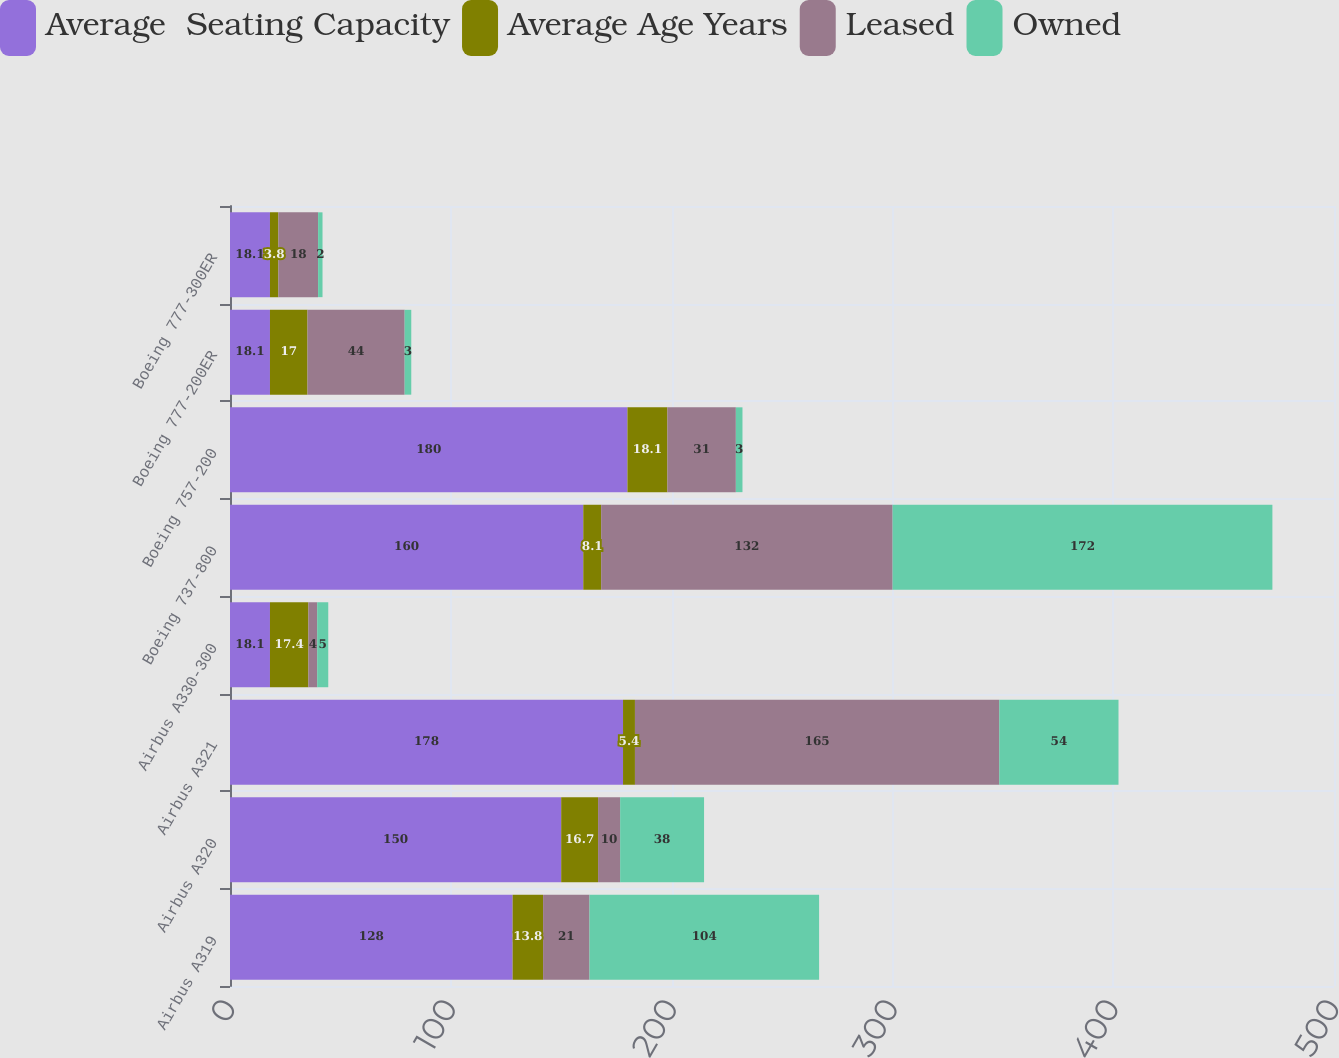Convert chart. <chart><loc_0><loc_0><loc_500><loc_500><stacked_bar_chart><ecel><fcel>Airbus A319<fcel>Airbus A320<fcel>Airbus A321<fcel>Airbus A330-300<fcel>Boeing 737-800<fcel>Boeing 757-200<fcel>Boeing 777-200ER<fcel>Boeing 777-300ER<nl><fcel>Average  Seating Capacity<fcel>128<fcel>150<fcel>178<fcel>18.1<fcel>160<fcel>180<fcel>18.1<fcel>18.1<nl><fcel>Average Age Years<fcel>13.8<fcel>16.7<fcel>5.4<fcel>17.4<fcel>8.1<fcel>18.1<fcel>17<fcel>3.8<nl><fcel>Leased<fcel>21<fcel>10<fcel>165<fcel>4<fcel>132<fcel>31<fcel>44<fcel>18<nl><fcel>Owned<fcel>104<fcel>38<fcel>54<fcel>5<fcel>172<fcel>3<fcel>3<fcel>2<nl></chart> 